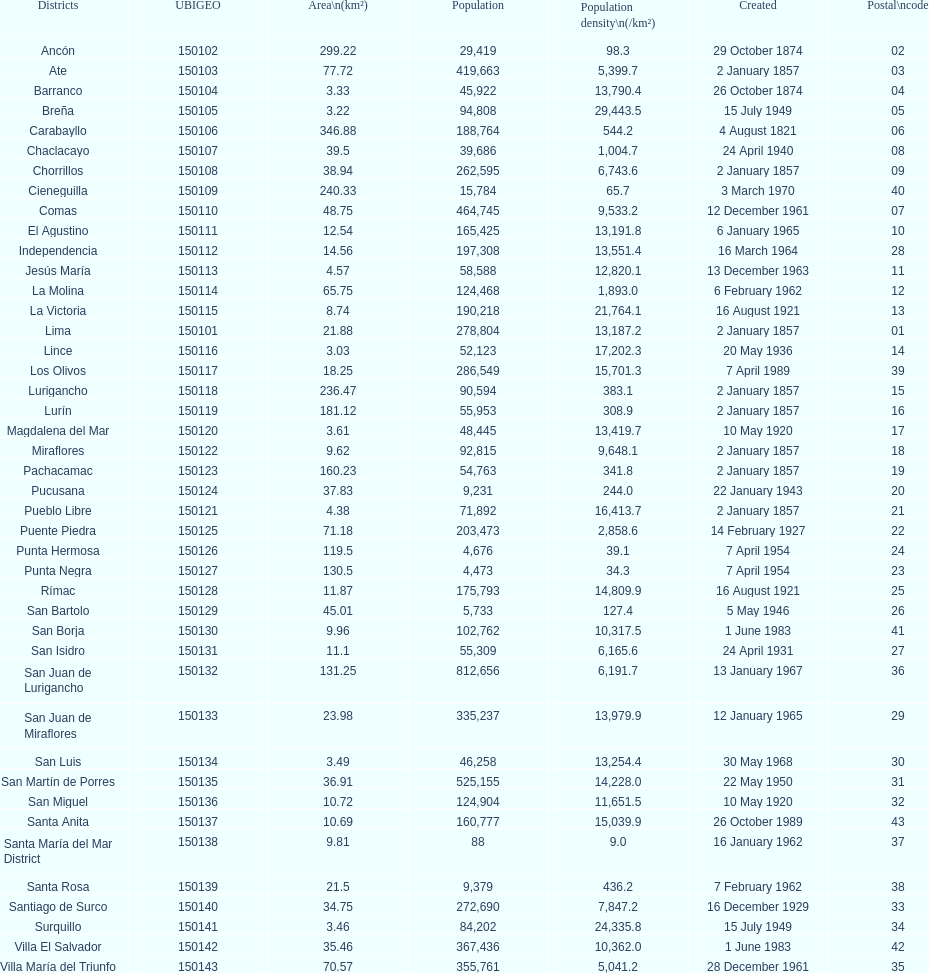What was the final district formed? Santa Anita. 